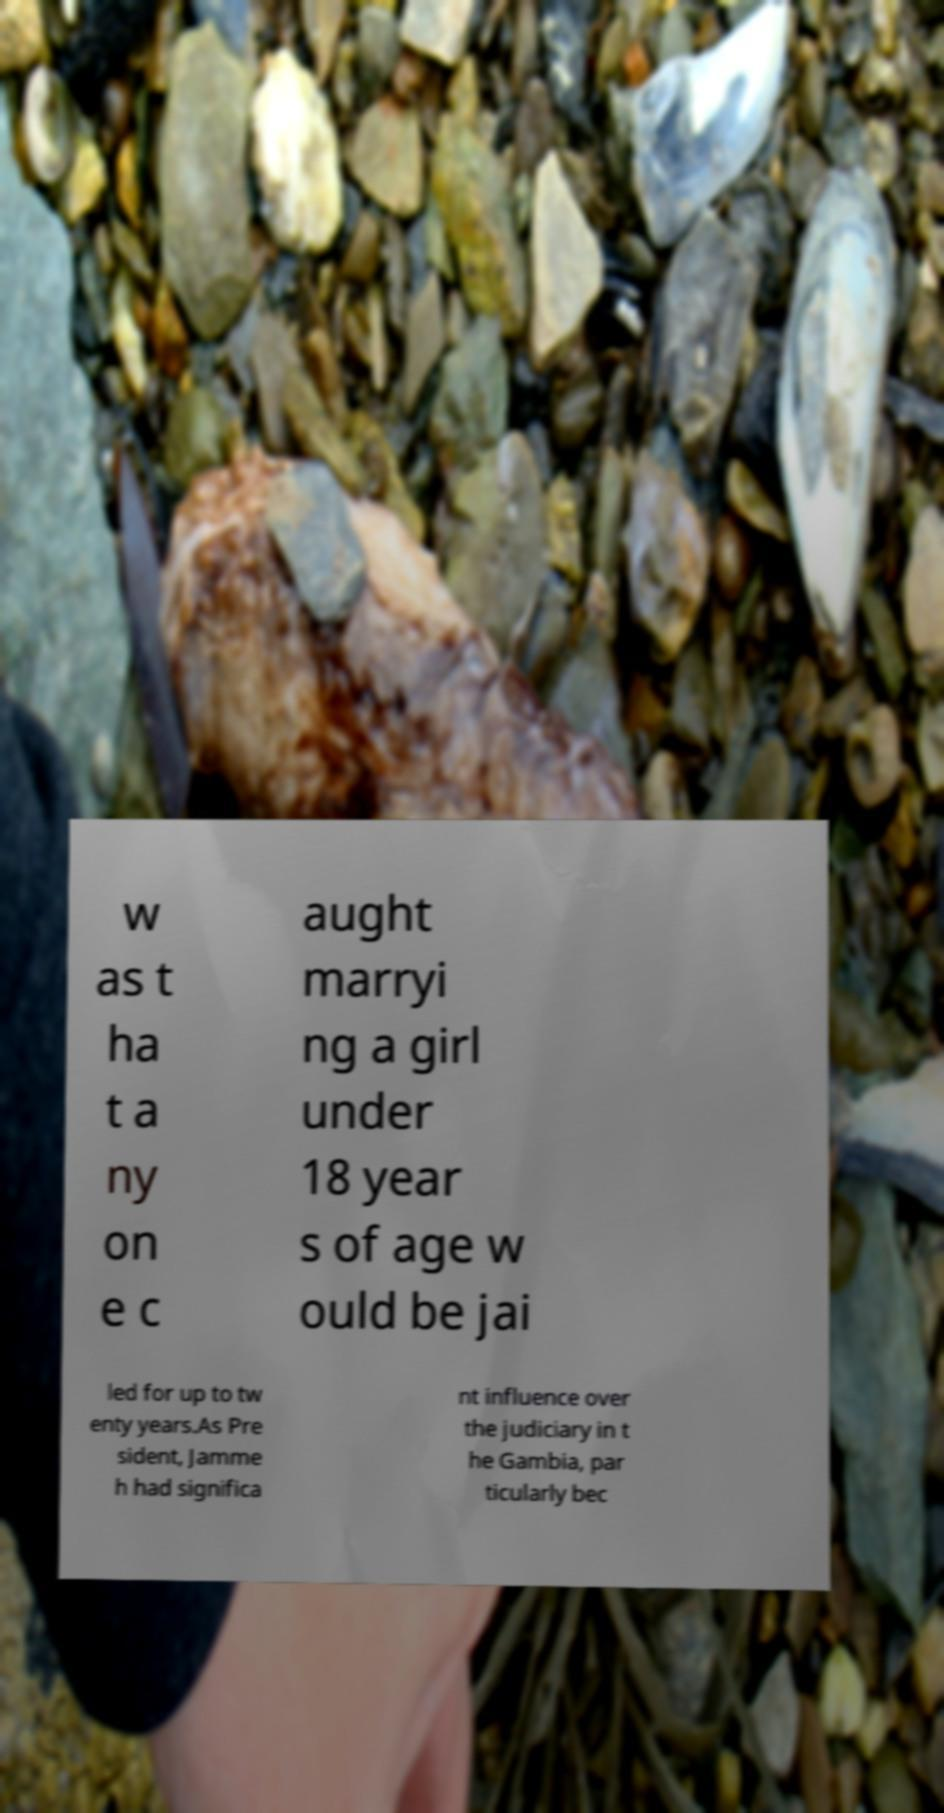There's text embedded in this image that I need extracted. Can you transcribe it verbatim? w as t ha t a ny on e c aught marryi ng a girl under 18 year s of age w ould be jai led for up to tw enty years.As Pre sident, Jamme h had significa nt influence over the judiciary in t he Gambia, par ticularly bec 